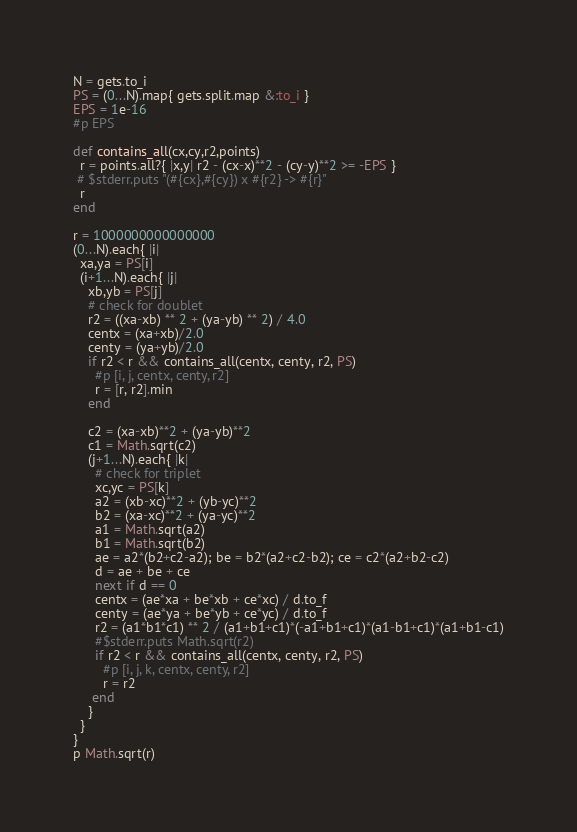<code> <loc_0><loc_0><loc_500><loc_500><_Ruby_>N = gets.to_i
PS = (0...N).map{ gets.split.map &:to_i }
EPS = 1e-16
#p EPS

def contains_all(cx,cy,r2,points)
  r = points.all?{ |x,y| r2 - (cx-x)**2 - (cy-y)**2 >= -EPS }
 # $stderr.puts "(#{cx},#{cy}) x #{r2} -> #{r}"
  r
end

r = 1000000000000000
(0...N).each{ |i|
  xa,ya = PS[i]
  (i+1...N).each{ |j|
    xb,yb = PS[j]
    # check for doublet
    r2 = ((xa-xb) ** 2 + (ya-yb) ** 2) / 4.0
    centx = (xa+xb)/2.0
    centy = (ya+yb)/2.0
    if r2 < r && contains_all(centx, centy, r2, PS)
      #p [i, j, centx, centy, r2]
      r = [r, r2].min
    end
    
  	c2 = (xa-xb)**2 + (ya-yb)**2
  	c1 = Math.sqrt(c2)
    (j+1...N).each{ |k|
      # check for triplet
      xc,yc = PS[k]
  	  a2 = (xb-xc)**2 + (yb-yc)**2
  	  b2 = (xa-xc)**2 + (ya-yc)**2
	  a1 = Math.sqrt(a2)
  	  b1 = Math.sqrt(b2)
      ae = a2*(b2+c2-a2); be = b2*(a2+c2-b2); ce = c2*(a2+b2-c2)
      d = ae + be + ce
      next if d == 0
      centx = (ae*xa + be*xb + ce*xc) / d.to_f
      centy = (ae*ya + be*yb + ce*yc) / d.to_f
      r2 = (a1*b1*c1) ** 2 / (a1+b1+c1)*(-a1+b1+c1)*(a1-b1+c1)*(a1+b1-c1)
      #$stderr.puts Math.sqrt(r2)
      if r2 < r && contains_all(centx, centy, r2, PS)
       	#p [i, j, k, centx, centy, r2]
      	r = r2
     end
    }
  }
}
p Math.sqrt(r)</code> 